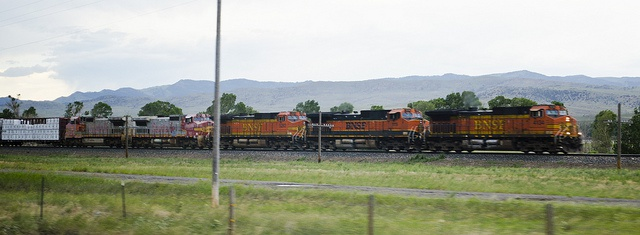Describe the objects in this image and their specific colors. I can see a train in lightgray, black, gray, maroon, and olive tones in this image. 